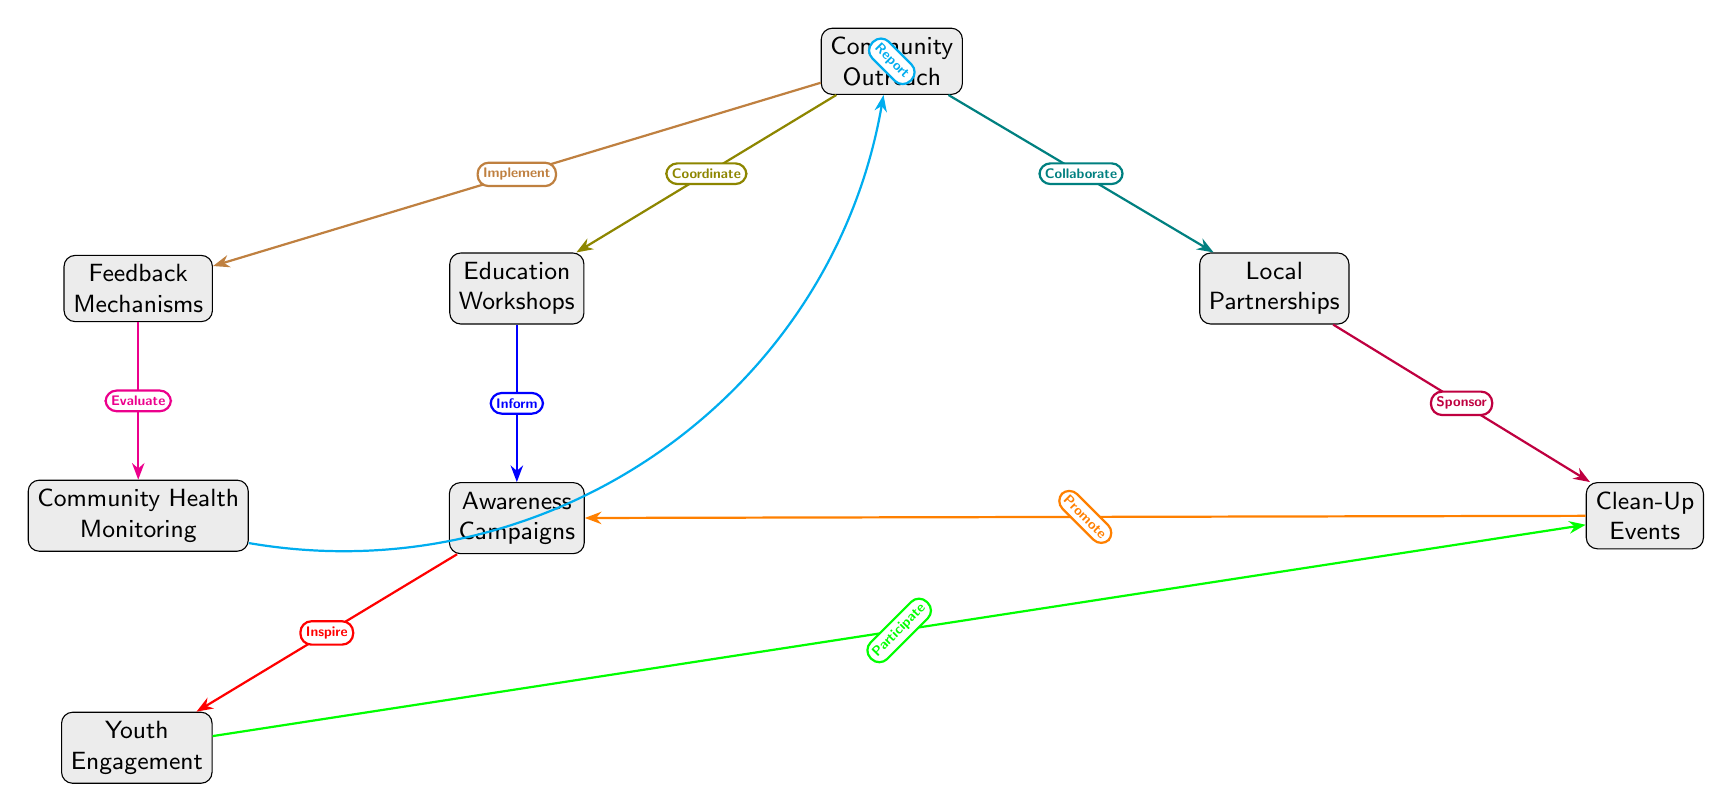What are the main nodes in the diagram? The main nodes represent key strategies for community engagement and awareness related to improving sanitary practices. By examining the diagram, we can identify that there are eight nodes: Community Outreach, Education Workshops, Local Partnerships, Clean-Up Events, Awareness Campaigns, Youth Engagement, Feedback Mechanisms, and Community Health Monitoring.
Answer: Community Outreach, Education Workshops, Local Partnerships, Clean-Up Events, Awareness Campaigns, Youth Engagement, Feedback Mechanisms, Community Health Monitoring How many edges connect to the Clean-Up Events node? The Clean-Up Events node has three incoming edges: one from Local Partnerships, one from Youth Engagement, and one from Awareness Campaigns. By counting the arrows pointing towards Clean-Up Events in the diagram, we find these three connections.
Answer: 3 What is the relationship between Community Outreach and Education Workshops? The relationship is noted as "Coordinate." This is evident from the arrow originating from Community Outreach pointing towards Education Workshops, with the label depicting their relationship.
Answer: Coordinate Which node inspires youth engagement? The node that inspires youth engagement is Awareness Campaigns. From the diagram, there is a direct arrow from Awareness Campaigns to Youth Engagement labeled "Inspire" which indicates that the purpose of Awareness Campaigns is to inspire youth participation.
Answer: Awareness Campaigns What action does the Local Partnerships node sponsor? Local Partnerships sponsors Clean-Up Events. By following the directed edge from Local Partnerships to Clean-Up Events, where the label reads "Sponsor," we can determine the action associated with the Local Partnerships node.
Answer: Clean-Up Events How does feedback from the community contribute to health monitoring? Feedback Mechanisms provide an evaluative role leading to Community Health Monitoring. The diagram shows an arrow from Feedback Mechanisms to Community Health Monitoring labeled "Evaluate," indicating that feedback is used to assess health conditions in the community.
Answer: Evaluate Which two nodes are directly connected to the Community Outreach node? The two nodes that are directly connected to Community Outreach are Education Workshops and Local Partnerships. By looking at the arrows coming out from Community Outreach in the diagram, we can see there are connections to both of these nodes.
Answer: Education Workshops, Local Partnerships What is the purpose of the awareness campaigns in relation to education workshops? The purpose of the awareness campaigns in relation to education workshops is to inform. The diagram shows a directed edge from Education Workshops to Awareness Campaigns labeled "Inform," highlighting this purpose.
Answer: Inform 